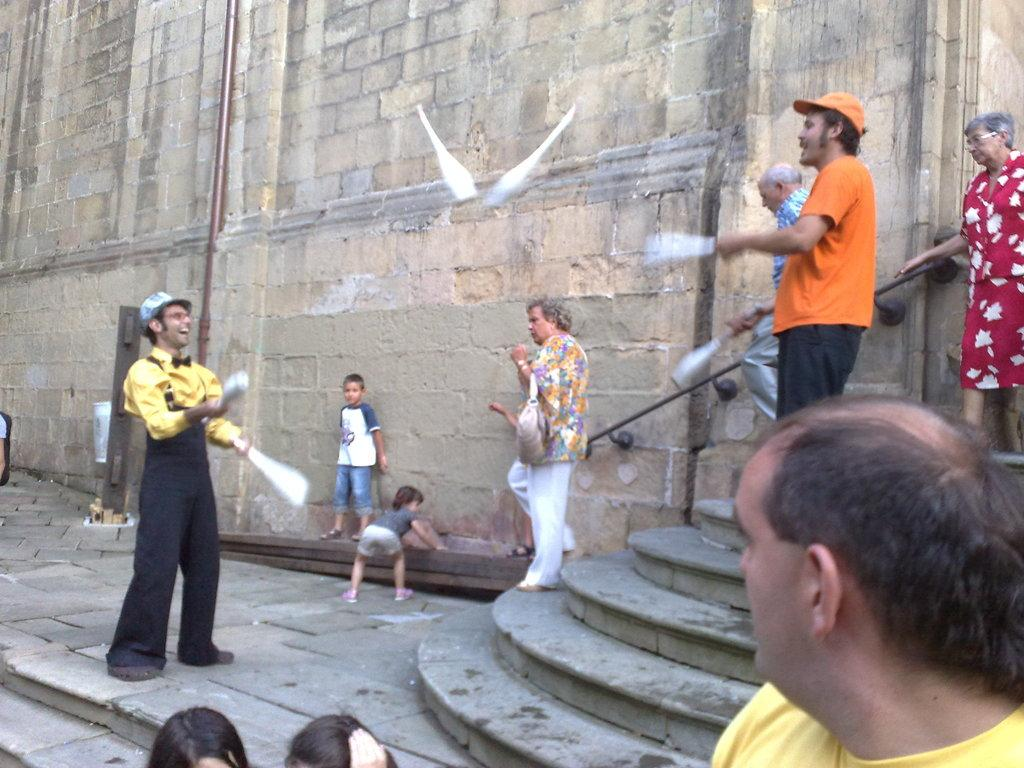How many people are in the image? There are two persons in the image. What are the two persons doing? The two persons are throwing bottles. What can be seen in the background of the image? There are people walking in the background, and there is a wall. Can you describe the location of the people walking in the background? The people are walking on steps in the background. Are there any children visible in the image? Yes, there are children near the wall in the image. What type of bee can be seen buzzing around the children in the image? There is no bee present in the image; it only features two persons throwing bottles, people walking on steps, a wall, and children near the wall. 